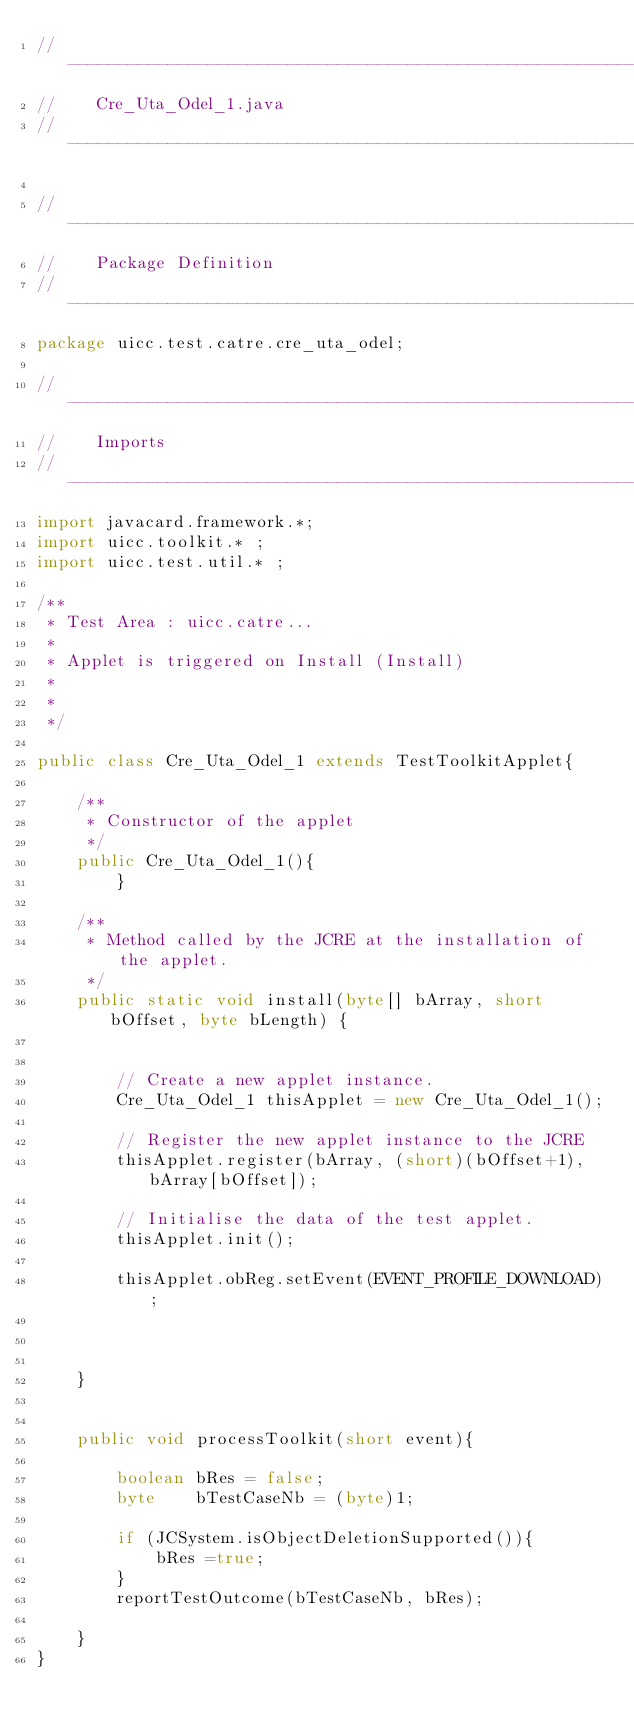Convert code to text. <code><loc_0><loc_0><loc_500><loc_500><_Java_>//-----------------------------------------------------------------------------
//    Cre_Uta_Odel_1.java
//-----------------------------------------------------------------------------

//-----------------------------------------------------------------------------
//    Package Definition
//-----------------------------------------------------------------------------
package uicc.test.catre.cre_uta_odel;

//-----------------------------------------------------------------------------
//    Imports
//-----------------------------------------------------------------------------
import javacard.framework.*;
import uicc.toolkit.* ;
import uicc.test.util.* ;

/**
 * Test Area : uicc.catre...
 *
 * Applet is triggered on Install (Install)
 *
 *
 */

public class Cre_Uta_Odel_1 extends TestToolkitApplet{

    /**
     * Constructor of the applet
     */
    public Cre_Uta_Odel_1(){
        }

    /**
     * Method called by the JCRE at the installation of the applet.
     */
    public static void install(byte[] bArray, short bOffset, byte bLength) {
              
        
        // Create a new applet instance.
        Cre_Uta_Odel_1 thisApplet = new Cre_Uta_Odel_1();

        // Register the new applet instance to the JCRE
        thisApplet.register(bArray, (short)(bOffset+1), bArray[bOffset]);

        // Initialise the data of the test applet.
        thisApplet.init();    
        
        thisApplet.obReg.setEvent(EVENT_PROFILE_DOWNLOAD);
        
       
   
    }


    public void processToolkit(short event){
                
        boolean bRes = false;
        byte    bTestCaseNb = (byte)1;

        if (JCSystem.isObjectDeletionSupported()){
            bRes =true;
        }        
        reportTestOutcome(bTestCaseNb, bRes);

    }
}
</code> 